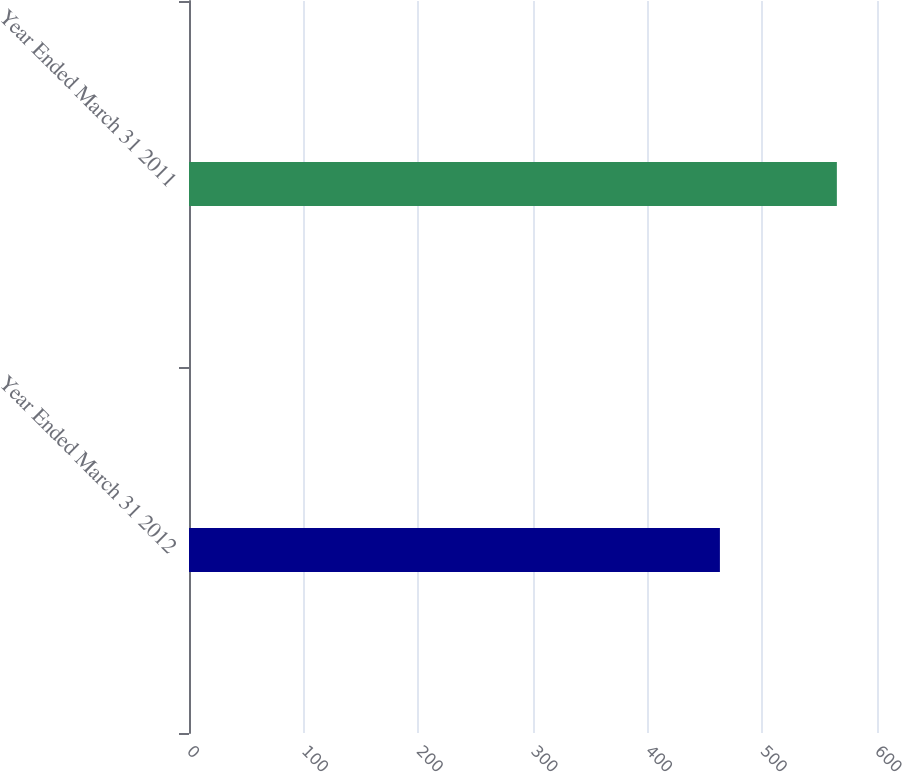Convert chart to OTSL. <chart><loc_0><loc_0><loc_500><loc_500><bar_chart><fcel>Year Ended March 31 2012<fcel>Year Ended March 31 2011<nl><fcel>463<fcel>565<nl></chart> 